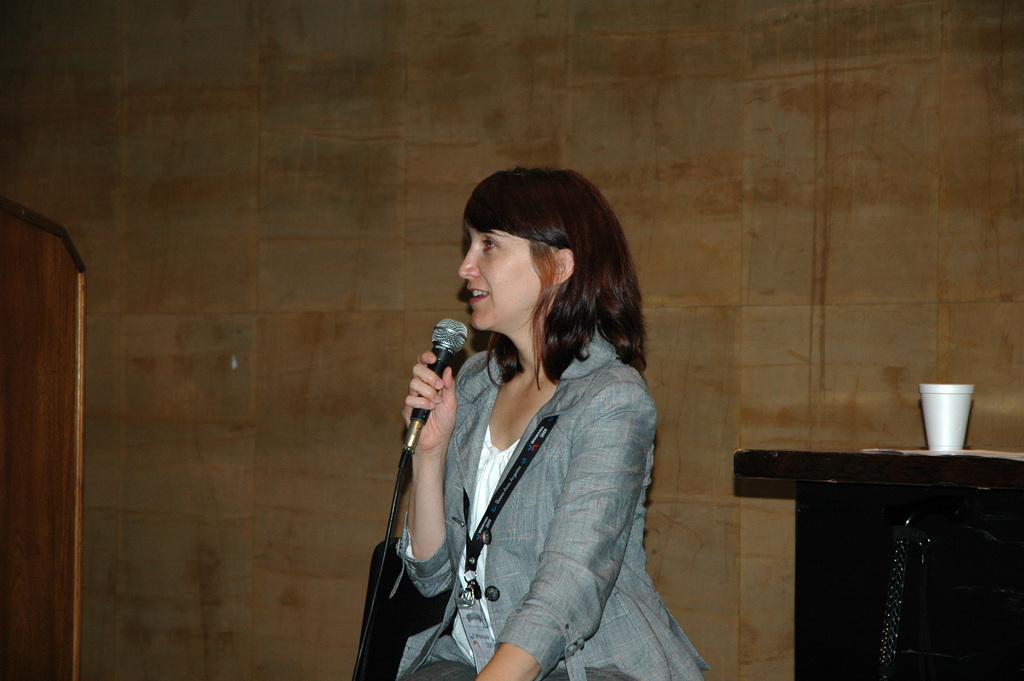Can you describe this image briefly? A lady with grey color jacket is sitting. She is holding a mic in her hand. To the right side there is a table. On the table there are two cups. 